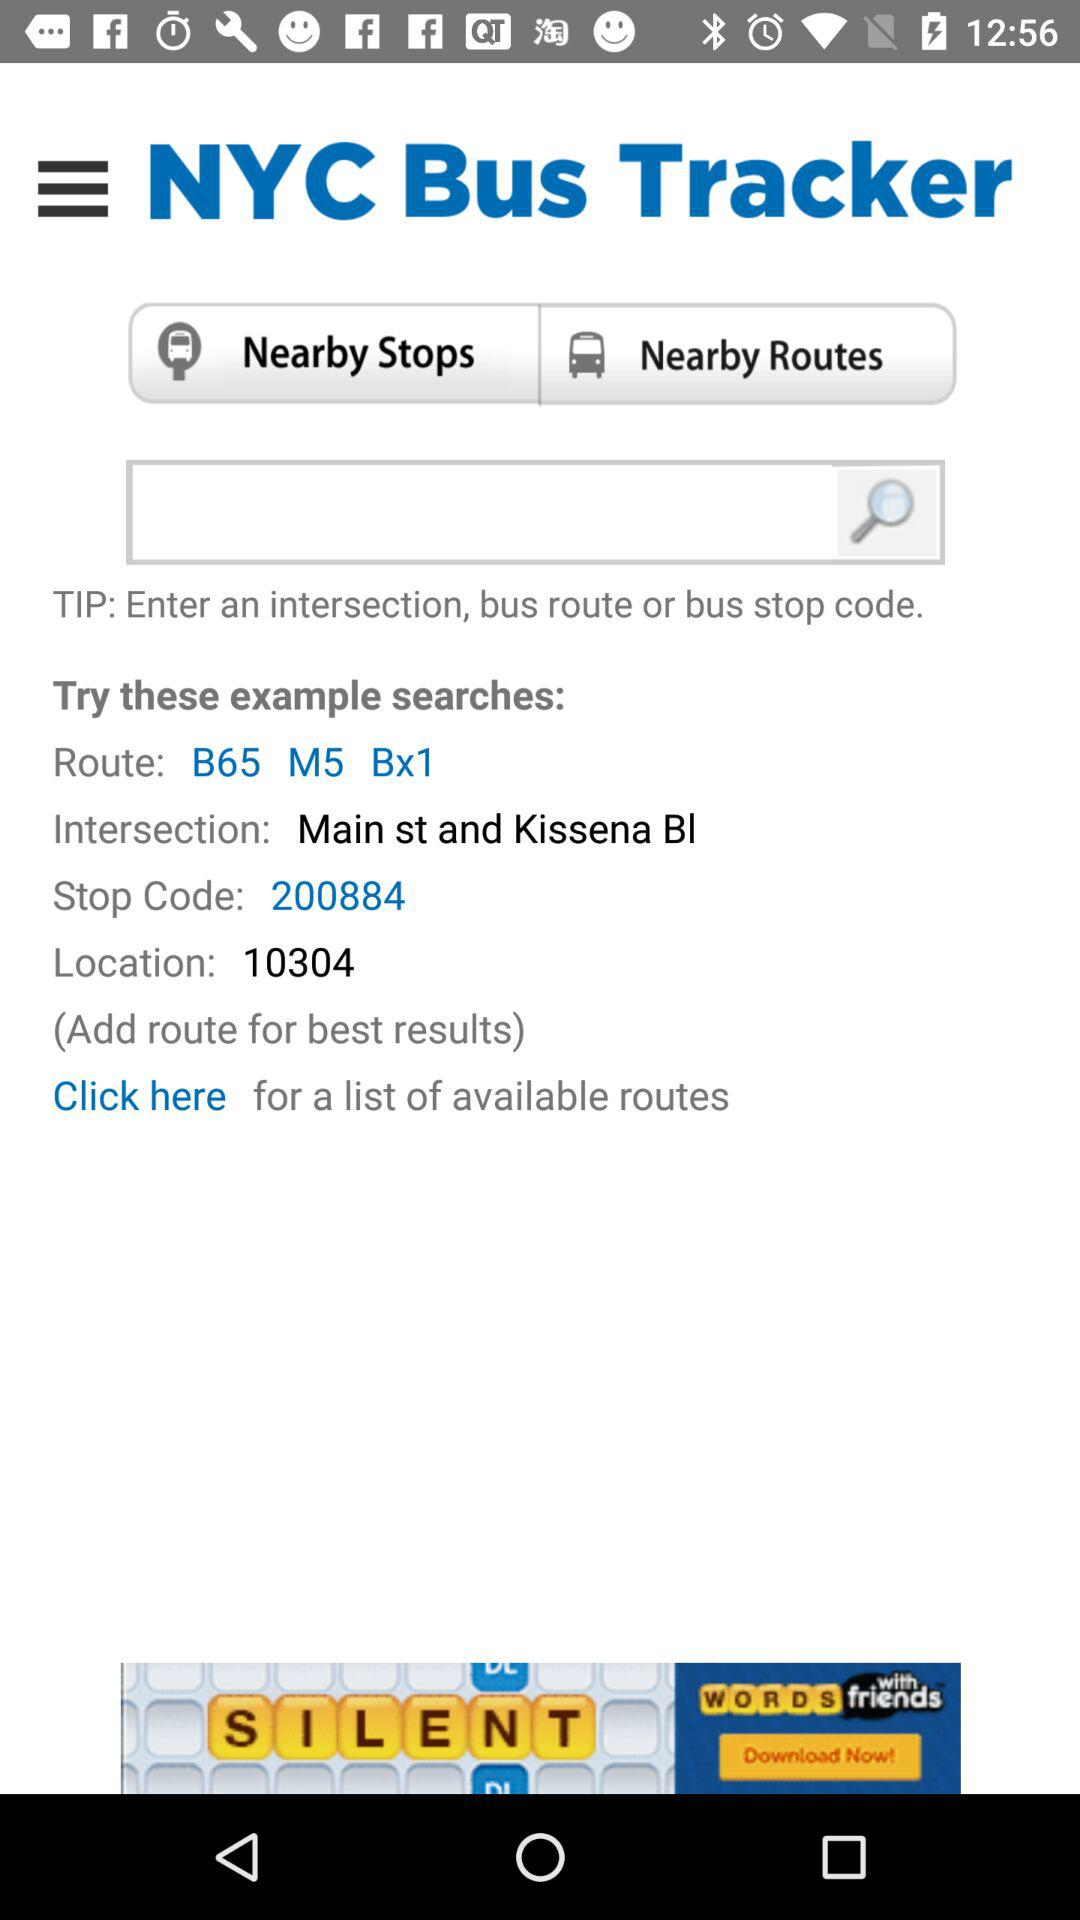What is the intersection? The intersection is Main St and Kissena BI. 